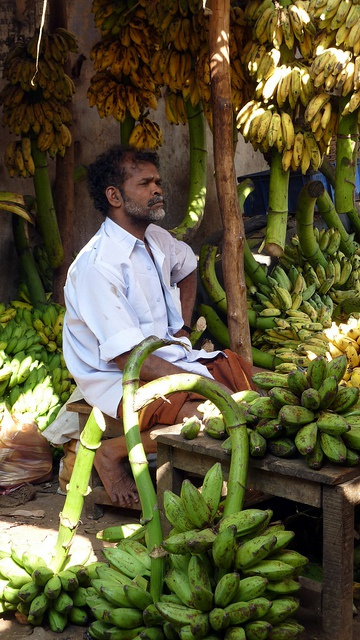Describe the objects in this image and their specific colors. I can see banana in black, olive, maroon, and ivory tones, people in black, lavender, maroon, and olive tones, banana in black, darkgreen, and olive tones, bench in black and gray tones, and banana in black, darkgreen, green, and olive tones in this image. 